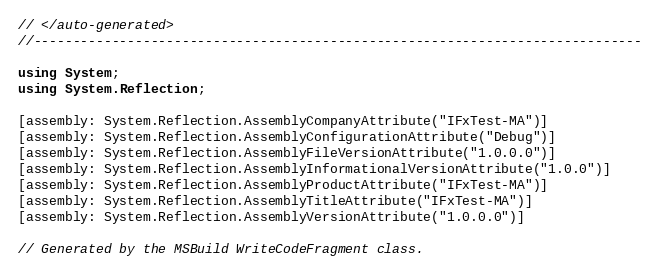<code> <loc_0><loc_0><loc_500><loc_500><_C#_>// </auto-generated>
//------------------------------------------------------------------------------

using System;
using System.Reflection;

[assembly: System.Reflection.AssemblyCompanyAttribute("IFxTest-MA")]
[assembly: System.Reflection.AssemblyConfigurationAttribute("Debug")]
[assembly: System.Reflection.AssemblyFileVersionAttribute("1.0.0.0")]
[assembly: System.Reflection.AssemblyInformationalVersionAttribute("1.0.0")]
[assembly: System.Reflection.AssemblyProductAttribute("IFxTest-MA")]
[assembly: System.Reflection.AssemblyTitleAttribute("IFxTest-MA")]
[assembly: System.Reflection.AssemblyVersionAttribute("1.0.0.0")]

// Generated by the MSBuild WriteCodeFragment class.

</code> 